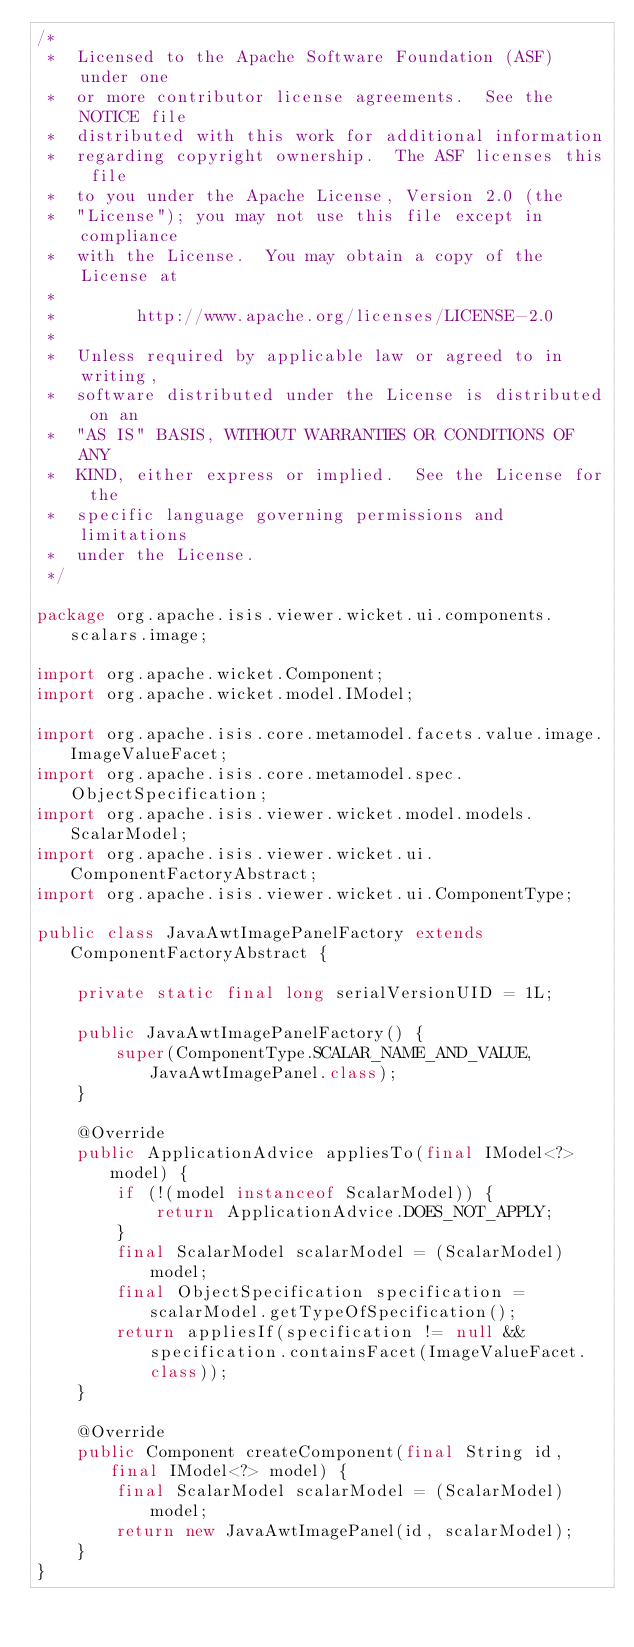Convert code to text. <code><loc_0><loc_0><loc_500><loc_500><_Java_>/*
 *  Licensed to the Apache Software Foundation (ASF) under one
 *  or more contributor license agreements.  See the NOTICE file
 *  distributed with this work for additional information
 *  regarding copyright ownership.  The ASF licenses this file
 *  to you under the Apache License, Version 2.0 (the
 *  "License"); you may not use this file except in compliance
 *  with the License.  You may obtain a copy of the License at
 *
 *        http://www.apache.org/licenses/LICENSE-2.0
 *
 *  Unless required by applicable law or agreed to in writing,
 *  software distributed under the License is distributed on an
 *  "AS IS" BASIS, WITHOUT WARRANTIES OR CONDITIONS OF ANY
 *  KIND, either express or implied.  See the License for the
 *  specific language governing permissions and limitations
 *  under the License.
 */

package org.apache.isis.viewer.wicket.ui.components.scalars.image;

import org.apache.wicket.Component;
import org.apache.wicket.model.IModel;

import org.apache.isis.core.metamodel.facets.value.image.ImageValueFacet;
import org.apache.isis.core.metamodel.spec.ObjectSpecification;
import org.apache.isis.viewer.wicket.model.models.ScalarModel;
import org.apache.isis.viewer.wicket.ui.ComponentFactoryAbstract;
import org.apache.isis.viewer.wicket.ui.ComponentType;

public class JavaAwtImagePanelFactory extends ComponentFactoryAbstract {

    private static final long serialVersionUID = 1L;

    public JavaAwtImagePanelFactory() {
        super(ComponentType.SCALAR_NAME_AND_VALUE, JavaAwtImagePanel.class);
    }

    @Override
    public ApplicationAdvice appliesTo(final IModel<?> model) {
        if (!(model instanceof ScalarModel)) {
            return ApplicationAdvice.DOES_NOT_APPLY;
        }
        final ScalarModel scalarModel = (ScalarModel) model;
        final ObjectSpecification specification = scalarModel.getTypeOfSpecification();
        return appliesIf(specification != null && specification.containsFacet(ImageValueFacet.class));
    }

    @Override
    public Component createComponent(final String id, final IModel<?> model) {
        final ScalarModel scalarModel = (ScalarModel) model;
        return new JavaAwtImagePanel(id, scalarModel);
    }
}
</code> 